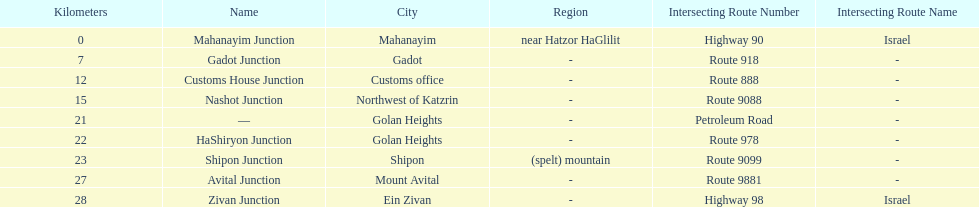Would you be able to parse every entry in this table? {'header': ['Kilometers', 'Name', 'City', 'Region', 'Intersecting Route Number', 'Intersecting Route Name'], 'rows': [['0', 'Mahanayim Junction', 'Mahanayim', 'near Hatzor HaGlilit', 'Highway 90', 'Israel'], ['7', 'Gadot Junction', 'Gadot', '-', 'Route 918', '-'], ['12', 'Customs House Junction', 'Customs office', '-', 'Route 888', '-'], ['15', 'Nashot Junction', 'Northwest of Katzrin', '-', 'Route 9088', '-'], ['21', '—', 'Golan Heights', '-', 'Petroleum Road', '-'], ['22', 'HaShiryon Junction', 'Golan Heights', '-', 'Route 978', '-'], ['23', 'Shipon Junction', 'Shipon', '(spelt) mountain', 'Route 9099', '-'], ['27', 'Avital Junction', 'Mount Avital', '-', 'Route 9881', '-'], ['28', 'Zivan Junction', 'Ein Zivan', '-', 'Highway 98', 'Israel']]} What is the number of routes that intersect highway 91? 9. 